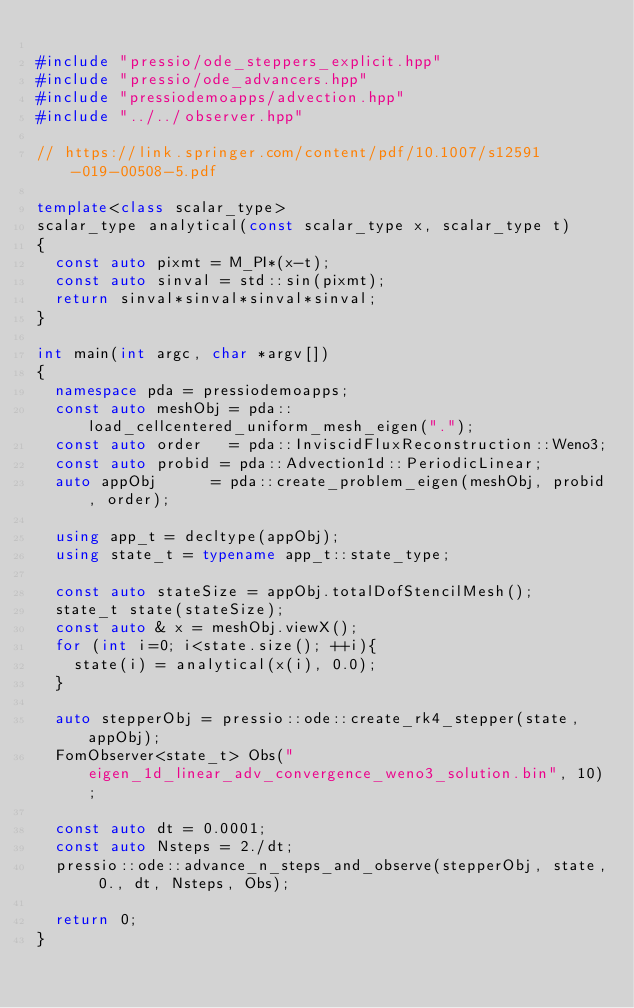<code> <loc_0><loc_0><loc_500><loc_500><_C++_>
#include "pressio/ode_steppers_explicit.hpp"
#include "pressio/ode_advancers.hpp"
#include "pressiodemoapps/advection.hpp"
#include "../../observer.hpp"

// https://link.springer.com/content/pdf/10.1007/s12591-019-00508-5.pdf

template<class scalar_type>
scalar_type analytical(const scalar_type x, scalar_type t)
{
  const auto pixmt = M_PI*(x-t);
  const auto sinval = std::sin(pixmt);
  return sinval*sinval*sinval*sinval;
}

int main(int argc, char *argv[])
{
  namespace pda = pressiodemoapps;
  const auto meshObj = pda::load_cellcentered_uniform_mesh_eigen(".");
  const auto order   = pda::InviscidFluxReconstruction::Weno3;
  const auto probid = pda::Advection1d::PeriodicLinear;
  auto appObj      = pda::create_problem_eigen(meshObj, probid, order);

  using app_t = decltype(appObj);
  using state_t = typename app_t::state_type;

  const auto stateSize = appObj.totalDofStencilMesh();
  state_t state(stateSize);
  const auto & x = meshObj.viewX();
  for (int i=0; i<state.size(); ++i){
    state(i) = analytical(x(i), 0.0);
  }

  auto stepperObj = pressio::ode::create_rk4_stepper(state, appObj);
  FomObserver<state_t> Obs("eigen_1d_linear_adv_convergence_weno3_solution.bin", 10);

  const auto dt = 0.0001;
  const auto Nsteps = 2./dt;
  pressio::ode::advance_n_steps_and_observe(stepperObj, state, 0., dt, Nsteps, Obs);

  return 0;
}
</code> 